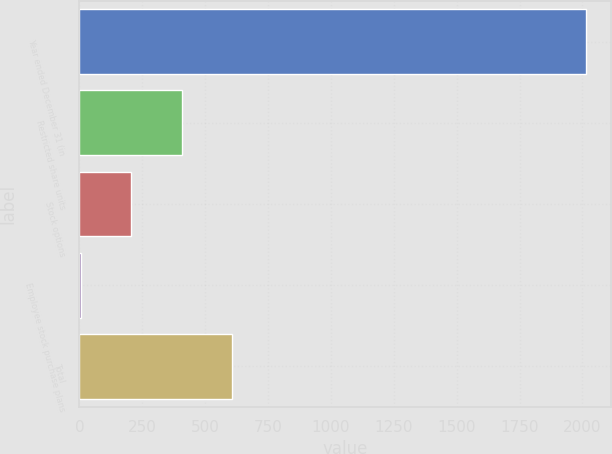Convert chart to OTSL. <chart><loc_0><loc_0><loc_500><loc_500><bar_chart><fcel>Year ended December 31 (in<fcel>Restricted share units<fcel>Stock options<fcel>Employee stock purchase plans<fcel>Total<nl><fcel>2014<fcel>407.6<fcel>206.8<fcel>6<fcel>608.4<nl></chart> 